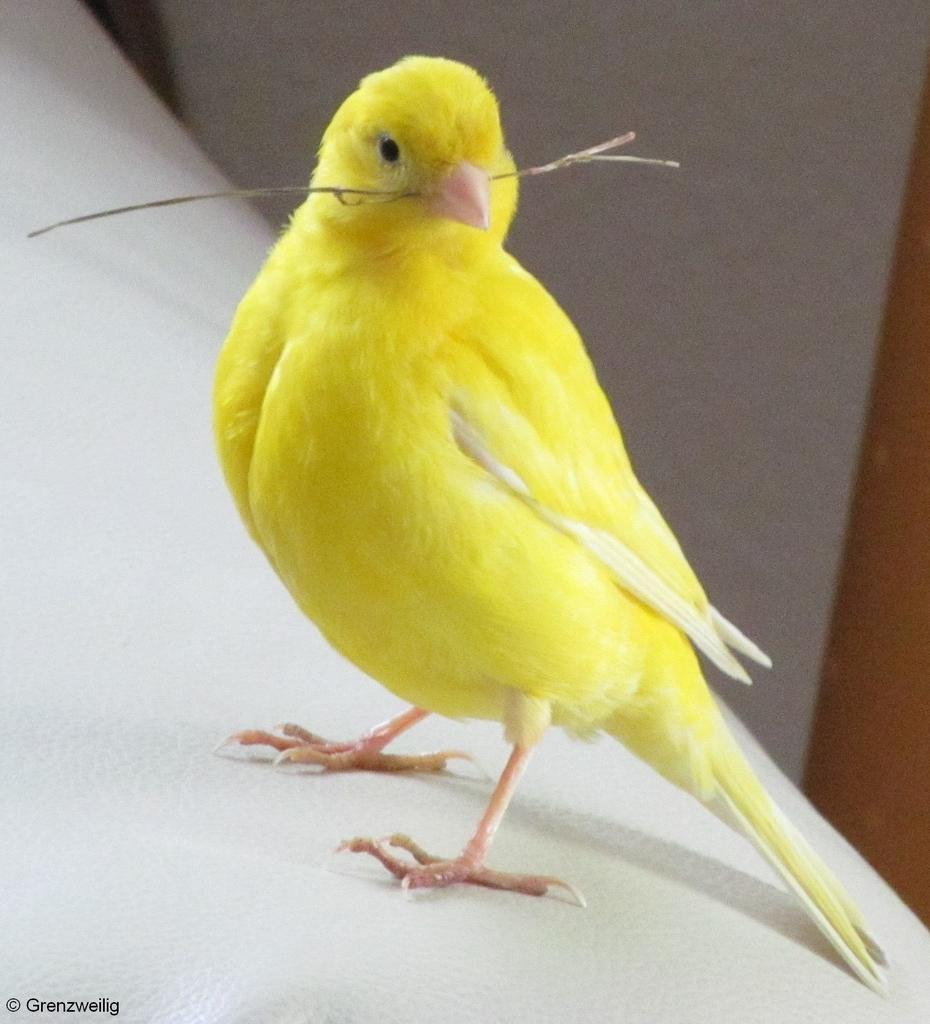What type of animal is in the image? There is a bird in the image. What color is the bird? The bird is yellow in color. What is the bird holding in its mouth? The bird is holding a small stem in its mouth. Where is the bird standing? The bird is standing on a wall. What can be seen in the background of the image? There is a wall visible in the background of the image. What title or caption is written on the wall in the image? There is no title or caption written on the wall in the image. What type of trousers is the bird wearing in the image? Birds do not wear trousers, and there is no indication of clothing in the image. 